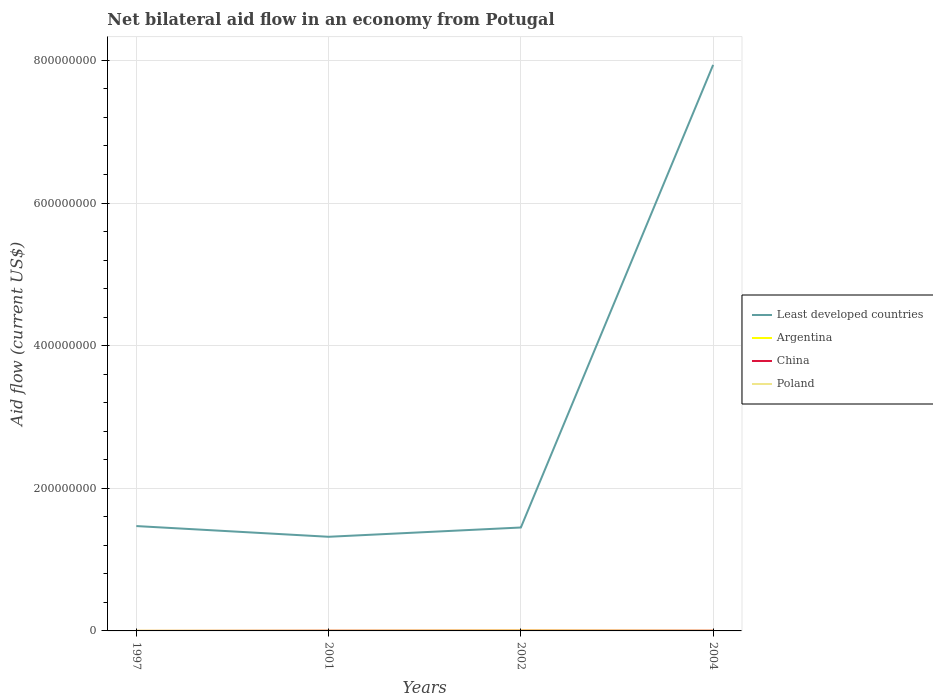Does the line corresponding to China intersect with the line corresponding to Least developed countries?
Make the answer very short. No. Is the number of lines equal to the number of legend labels?
Ensure brevity in your answer.  Yes. Across all years, what is the maximum net bilateral aid flow in Poland?
Your response must be concise. 9.00e+04. In which year was the net bilateral aid flow in Poland maximum?
Keep it short and to the point. 2001. What is the difference between the highest and the second highest net bilateral aid flow in Least developed countries?
Provide a succinct answer. 6.62e+08. Is the net bilateral aid flow in Poland strictly greater than the net bilateral aid flow in Argentina over the years?
Your answer should be compact. No. How many lines are there?
Offer a terse response. 4. What is the difference between two consecutive major ticks on the Y-axis?
Offer a very short reply. 2.00e+08. Are the values on the major ticks of Y-axis written in scientific E-notation?
Ensure brevity in your answer.  No. Does the graph contain any zero values?
Your answer should be compact. No. Does the graph contain grids?
Offer a very short reply. Yes. Where does the legend appear in the graph?
Offer a very short reply. Center right. How are the legend labels stacked?
Offer a terse response. Vertical. What is the title of the graph?
Provide a succinct answer. Net bilateral aid flow in an economy from Potugal. Does "Mali" appear as one of the legend labels in the graph?
Your answer should be very brief. No. What is the label or title of the X-axis?
Ensure brevity in your answer.  Years. What is the label or title of the Y-axis?
Ensure brevity in your answer.  Aid flow (current US$). What is the Aid flow (current US$) of Least developed countries in 1997?
Offer a terse response. 1.47e+08. What is the Aid flow (current US$) in China in 1997?
Make the answer very short. 10000. What is the Aid flow (current US$) of Poland in 1997?
Your response must be concise. 2.10e+05. What is the Aid flow (current US$) of Least developed countries in 2001?
Keep it short and to the point. 1.32e+08. What is the Aid flow (current US$) in China in 2001?
Offer a terse response. 2.60e+05. What is the Aid flow (current US$) of Least developed countries in 2002?
Keep it short and to the point. 1.45e+08. What is the Aid flow (current US$) of Argentina in 2002?
Your answer should be very brief. 5.10e+05. What is the Aid flow (current US$) of China in 2002?
Your response must be concise. 2.70e+05. What is the Aid flow (current US$) in Least developed countries in 2004?
Give a very brief answer. 7.94e+08. What is the Aid flow (current US$) in Poland in 2004?
Provide a succinct answer. 1.20e+05. Across all years, what is the maximum Aid flow (current US$) of Least developed countries?
Make the answer very short. 7.94e+08. Across all years, what is the maximum Aid flow (current US$) of Argentina?
Make the answer very short. 5.10e+05. Across all years, what is the maximum Aid flow (current US$) of China?
Your answer should be very brief. 3.00e+05. Across all years, what is the minimum Aid flow (current US$) of Least developed countries?
Provide a succinct answer. 1.32e+08. Across all years, what is the minimum Aid flow (current US$) in China?
Provide a succinct answer. 10000. Across all years, what is the minimum Aid flow (current US$) of Poland?
Give a very brief answer. 9.00e+04. What is the total Aid flow (current US$) of Least developed countries in the graph?
Keep it short and to the point. 1.22e+09. What is the total Aid flow (current US$) of Argentina in the graph?
Offer a terse response. 7.50e+05. What is the total Aid flow (current US$) in China in the graph?
Provide a succinct answer. 8.40e+05. What is the total Aid flow (current US$) of Poland in the graph?
Your answer should be very brief. 5.60e+05. What is the difference between the Aid flow (current US$) of Least developed countries in 1997 and that in 2001?
Offer a very short reply. 1.50e+07. What is the difference between the Aid flow (current US$) in Argentina in 1997 and that in 2001?
Your answer should be compact. -1.00e+05. What is the difference between the Aid flow (current US$) in Least developed countries in 1997 and that in 2002?
Keep it short and to the point. 2.02e+06. What is the difference between the Aid flow (current US$) in Argentina in 1997 and that in 2002?
Your response must be concise. -4.80e+05. What is the difference between the Aid flow (current US$) in Least developed countries in 1997 and that in 2004?
Your answer should be very brief. -6.47e+08. What is the difference between the Aid flow (current US$) of China in 1997 and that in 2004?
Offer a very short reply. -2.90e+05. What is the difference between the Aid flow (current US$) of Poland in 1997 and that in 2004?
Your answer should be compact. 9.00e+04. What is the difference between the Aid flow (current US$) in Least developed countries in 2001 and that in 2002?
Give a very brief answer. -1.30e+07. What is the difference between the Aid flow (current US$) of Argentina in 2001 and that in 2002?
Ensure brevity in your answer.  -3.80e+05. What is the difference between the Aid flow (current US$) in Least developed countries in 2001 and that in 2004?
Offer a terse response. -6.62e+08. What is the difference between the Aid flow (current US$) in Argentina in 2001 and that in 2004?
Your answer should be very brief. 5.00e+04. What is the difference between the Aid flow (current US$) in China in 2001 and that in 2004?
Offer a terse response. -4.00e+04. What is the difference between the Aid flow (current US$) in Poland in 2001 and that in 2004?
Keep it short and to the point. -3.00e+04. What is the difference between the Aid flow (current US$) in Least developed countries in 2002 and that in 2004?
Your answer should be compact. -6.49e+08. What is the difference between the Aid flow (current US$) in Poland in 2002 and that in 2004?
Your response must be concise. 2.00e+04. What is the difference between the Aid flow (current US$) of Least developed countries in 1997 and the Aid flow (current US$) of Argentina in 2001?
Ensure brevity in your answer.  1.47e+08. What is the difference between the Aid flow (current US$) in Least developed countries in 1997 and the Aid flow (current US$) in China in 2001?
Provide a succinct answer. 1.47e+08. What is the difference between the Aid flow (current US$) in Least developed countries in 1997 and the Aid flow (current US$) in Poland in 2001?
Offer a terse response. 1.47e+08. What is the difference between the Aid flow (current US$) in Least developed countries in 1997 and the Aid flow (current US$) in Argentina in 2002?
Offer a terse response. 1.47e+08. What is the difference between the Aid flow (current US$) in Least developed countries in 1997 and the Aid flow (current US$) in China in 2002?
Your answer should be very brief. 1.47e+08. What is the difference between the Aid flow (current US$) in Least developed countries in 1997 and the Aid flow (current US$) in Poland in 2002?
Ensure brevity in your answer.  1.47e+08. What is the difference between the Aid flow (current US$) in Argentina in 1997 and the Aid flow (current US$) in China in 2002?
Give a very brief answer. -2.40e+05. What is the difference between the Aid flow (current US$) of Argentina in 1997 and the Aid flow (current US$) of Poland in 2002?
Offer a terse response. -1.10e+05. What is the difference between the Aid flow (current US$) in Least developed countries in 1997 and the Aid flow (current US$) in Argentina in 2004?
Your response must be concise. 1.47e+08. What is the difference between the Aid flow (current US$) in Least developed countries in 1997 and the Aid flow (current US$) in China in 2004?
Make the answer very short. 1.47e+08. What is the difference between the Aid flow (current US$) in Least developed countries in 1997 and the Aid flow (current US$) in Poland in 2004?
Your answer should be very brief. 1.47e+08. What is the difference between the Aid flow (current US$) of Argentina in 1997 and the Aid flow (current US$) of China in 2004?
Keep it short and to the point. -2.70e+05. What is the difference between the Aid flow (current US$) of China in 1997 and the Aid flow (current US$) of Poland in 2004?
Ensure brevity in your answer.  -1.10e+05. What is the difference between the Aid flow (current US$) in Least developed countries in 2001 and the Aid flow (current US$) in Argentina in 2002?
Your response must be concise. 1.31e+08. What is the difference between the Aid flow (current US$) of Least developed countries in 2001 and the Aid flow (current US$) of China in 2002?
Ensure brevity in your answer.  1.32e+08. What is the difference between the Aid flow (current US$) in Least developed countries in 2001 and the Aid flow (current US$) in Poland in 2002?
Make the answer very short. 1.32e+08. What is the difference between the Aid flow (current US$) of Argentina in 2001 and the Aid flow (current US$) of China in 2002?
Ensure brevity in your answer.  -1.40e+05. What is the difference between the Aid flow (current US$) in Argentina in 2001 and the Aid flow (current US$) in Poland in 2002?
Offer a terse response. -10000. What is the difference between the Aid flow (current US$) in Least developed countries in 2001 and the Aid flow (current US$) in Argentina in 2004?
Provide a short and direct response. 1.32e+08. What is the difference between the Aid flow (current US$) of Least developed countries in 2001 and the Aid flow (current US$) of China in 2004?
Offer a terse response. 1.32e+08. What is the difference between the Aid flow (current US$) in Least developed countries in 2001 and the Aid flow (current US$) in Poland in 2004?
Keep it short and to the point. 1.32e+08. What is the difference between the Aid flow (current US$) of Argentina in 2001 and the Aid flow (current US$) of China in 2004?
Keep it short and to the point. -1.70e+05. What is the difference between the Aid flow (current US$) of China in 2001 and the Aid flow (current US$) of Poland in 2004?
Give a very brief answer. 1.40e+05. What is the difference between the Aid flow (current US$) in Least developed countries in 2002 and the Aid flow (current US$) in Argentina in 2004?
Your answer should be very brief. 1.45e+08. What is the difference between the Aid flow (current US$) in Least developed countries in 2002 and the Aid flow (current US$) in China in 2004?
Provide a succinct answer. 1.45e+08. What is the difference between the Aid flow (current US$) of Least developed countries in 2002 and the Aid flow (current US$) of Poland in 2004?
Ensure brevity in your answer.  1.45e+08. What is the difference between the Aid flow (current US$) of Argentina in 2002 and the Aid flow (current US$) of China in 2004?
Make the answer very short. 2.10e+05. What is the average Aid flow (current US$) of Least developed countries per year?
Keep it short and to the point. 3.04e+08. What is the average Aid flow (current US$) in Argentina per year?
Your answer should be very brief. 1.88e+05. What is the average Aid flow (current US$) of Poland per year?
Ensure brevity in your answer.  1.40e+05. In the year 1997, what is the difference between the Aid flow (current US$) in Least developed countries and Aid flow (current US$) in Argentina?
Provide a succinct answer. 1.47e+08. In the year 1997, what is the difference between the Aid flow (current US$) in Least developed countries and Aid flow (current US$) in China?
Your response must be concise. 1.47e+08. In the year 1997, what is the difference between the Aid flow (current US$) of Least developed countries and Aid flow (current US$) of Poland?
Keep it short and to the point. 1.47e+08. In the year 2001, what is the difference between the Aid flow (current US$) of Least developed countries and Aid flow (current US$) of Argentina?
Your answer should be very brief. 1.32e+08. In the year 2001, what is the difference between the Aid flow (current US$) in Least developed countries and Aid flow (current US$) in China?
Make the answer very short. 1.32e+08. In the year 2001, what is the difference between the Aid flow (current US$) of Least developed countries and Aid flow (current US$) of Poland?
Offer a very short reply. 1.32e+08. In the year 2001, what is the difference between the Aid flow (current US$) of Argentina and Aid flow (current US$) of Poland?
Provide a succinct answer. 4.00e+04. In the year 2001, what is the difference between the Aid flow (current US$) in China and Aid flow (current US$) in Poland?
Offer a terse response. 1.70e+05. In the year 2002, what is the difference between the Aid flow (current US$) in Least developed countries and Aid flow (current US$) in Argentina?
Keep it short and to the point. 1.44e+08. In the year 2002, what is the difference between the Aid flow (current US$) in Least developed countries and Aid flow (current US$) in China?
Keep it short and to the point. 1.45e+08. In the year 2002, what is the difference between the Aid flow (current US$) of Least developed countries and Aid flow (current US$) of Poland?
Your response must be concise. 1.45e+08. In the year 2002, what is the difference between the Aid flow (current US$) of Argentina and Aid flow (current US$) of Poland?
Your answer should be compact. 3.70e+05. In the year 2002, what is the difference between the Aid flow (current US$) of China and Aid flow (current US$) of Poland?
Provide a succinct answer. 1.30e+05. In the year 2004, what is the difference between the Aid flow (current US$) in Least developed countries and Aid flow (current US$) in Argentina?
Your answer should be compact. 7.94e+08. In the year 2004, what is the difference between the Aid flow (current US$) in Least developed countries and Aid flow (current US$) in China?
Your answer should be very brief. 7.93e+08. In the year 2004, what is the difference between the Aid flow (current US$) of Least developed countries and Aid flow (current US$) of Poland?
Make the answer very short. 7.94e+08. In the year 2004, what is the difference between the Aid flow (current US$) of Argentina and Aid flow (current US$) of China?
Provide a short and direct response. -2.20e+05. In the year 2004, what is the difference between the Aid flow (current US$) of Argentina and Aid flow (current US$) of Poland?
Ensure brevity in your answer.  -4.00e+04. What is the ratio of the Aid flow (current US$) in Least developed countries in 1997 to that in 2001?
Provide a succinct answer. 1.11. What is the ratio of the Aid flow (current US$) in Argentina in 1997 to that in 2001?
Ensure brevity in your answer.  0.23. What is the ratio of the Aid flow (current US$) of China in 1997 to that in 2001?
Your answer should be very brief. 0.04. What is the ratio of the Aid flow (current US$) in Poland in 1997 to that in 2001?
Provide a short and direct response. 2.33. What is the ratio of the Aid flow (current US$) in Least developed countries in 1997 to that in 2002?
Give a very brief answer. 1.01. What is the ratio of the Aid flow (current US$) in Argentina in 1997 to that in 2002?
Make the answer very short. 0.06. What is the ratio of the Aid flow (current US$) of China in 1997 to that in 2002?
Your response must be concise. 0.04. What is the ratio of the Aid flow (current US$) in Poland in 1997 to that in 2002?
Give a very brief answer. 1.5. What is the ratio of the Aid flow (current US$) of Least developed countries in 1997 to that in 2004?
Offer a very short reply. 0.19. What is the ratio of the Aid flow (current US$) in Argentina in 1997 to that in 2004?
Offer a very short reply. 0.38. What is the ratio of the Aid flow (current US$) of Poland in 1997 to that in 2004?
Your answer should be very brief. 1.75. What is the ratio of the Aid flow (current US$) of Least developed countries in 2001 to that in 2002?
Offer a very short reply. 0.91. What is the ratio of the Aid flow (current US$) of Argentina in 2001 to that in 2002?
Keep it short and to the point. 0.25. What is the ratio of the Aid flow (current US$) in China in 2001 to that in 2002?
Give a very brief answer. 0.96. What is the ratio of the Aid flow (current US$) of Poland in 2001 to that in 2002?
Make the answer very short. 0.64. What is the ratio of the Aid flow (current US$) in Least developed countries in 2001 to that in 2004?
Your response must be concise. 0.17. What is the ratio of the Aid flow (current US$) in Argentina in 2001 to that in 2004?
Offer a very short reply. 1.62. What is the ratio of the Aid flow (current US$) of China in 2001 to that in 2004?
Offer a terse response. 0.87. What is the ratio of the Aid flow (current US$) in Least developed countries in 2002 to that in 2004?
Offer a terse response. 0.18. What is the ratio of the Aid flow (current US$) in Argentina in 2002 to that in 2004?
Your response must be concise. 6.38. What is the ratio of the Aid flow (current US$) in Poland in 2002 to that in 2004?
Provide a succinct answer. 1.17. What is the difference between the highest and the second highest Aid flow (current US$) of Least developed countries?
Your answer should be compact. 6.47e+08. What is the difference between the highest and the second highest Aid flow (current US$) in China?
Make the answer very short. 3.00e+04. What is the difference between the highest and the lowest Aid flow (current US$) in Least developed countries?
Make the answer very short. 6.62e+08. What is the difference between the highest and the lowest Aid flow (current US$) of China?
Your response must be concise. 2.90e+05. 